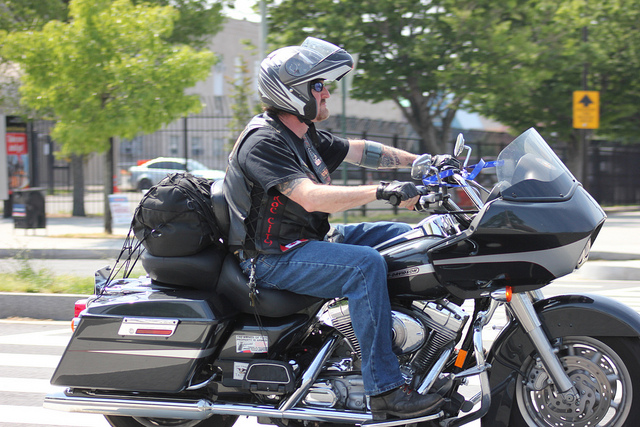Can you describe the rider's safety gear? Certainly! The rider is wearing a full-faced helmet for maximum protection, along with what appears to be a reinforced jacket, gloves, and potentially armored pants to ensure safety while riding. 